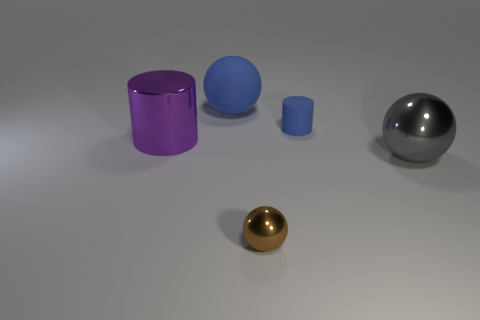Add 1 big shiny cylinders. How many objects exist? 6 Subtract all spheres. How many objects are left? 2 Subtract 0 brown blocks. How many objects are left? 5 Subtract all purple cylinders. Subtract all small brown metallic things. How many objects are left? 3 Add 1 large purple shiny objects. How many large purple shiny objects are left? 2 Add 5 large purple cylinders. How many large purple cylinders exist? 6 